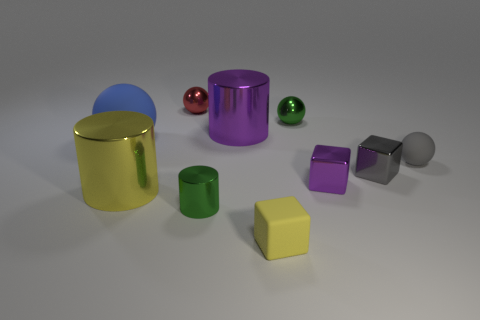Are there any reflective surfaces visible in the picture? Yes, multiple objects have reflective surfaces, evident by the light reflections and visible surroundings captured on their surfaces. 